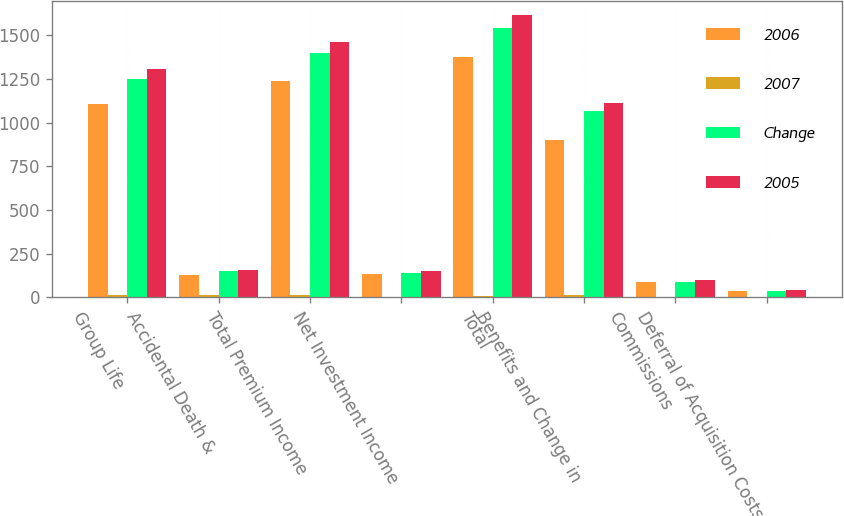<chart> <loc_0><loc_0><loc_500><loc_500><stacked_bar_chart><ecel><fcel>Group Life<fcel>Accidental Death &<fcel>Total Premium Income<fcel>Net Investment Income<fcel>Total<fcel>Benefits and Change in<fcel>Commissions<fcel>Deferral of Acquisition Costs<nl><fcel>2006<fcel>1107.4<fcel>131<fcel>1238.4<fcel>134.9<fcel>1375.7<fcel>901.6<fcel>88.7<fcel>36.1<nl><fcel>2007<fcel>11.3<fcel>13.6<fcel>11.5<fcel>4.5<fcel>10.7<fcel>15.5<fcel>1.6<fcel>4.2<nl><fcel>Change<fcel>1248.1<fcel>151.6<fcel>1399.7<fcel>141.3<fcel>1541<fcel>1067.3<fcel>90.1<fcel>37.7<nl><fcel>2005<fcel>1306.8<fcel>156.4<fcel>1463.2<fcel>151.9<fcel>1617.1<fcel>1111.9<fcel>97.8<fcel>42.7<nl></chart> 